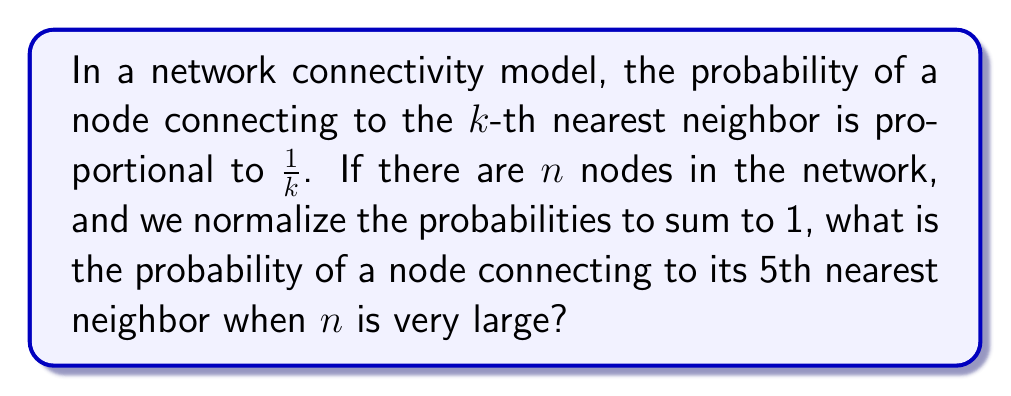What is the answer to this math problem? Let's approach this step-by-step:

1) The probability of connecting to the $k$-th nearest neighbor is proportional to $\frac{1}{k}$. This means we can write the probability as:

   $$P(k) = \frac{C}{k}$$

   where $C$ is a normalization constant.

2) To find $C$, we use the fact that the sum of all probabilities must equal 1:

   $$\sum_{k=1}^{n} P(k) = 1$$

3) Substituting our expression for $P(k)$:

   $$\sum_{k=1}^{n} \frac{C}{k} = 1$$

4) This sum is the partial sum of the harmonic series. As $n$ becomes very large, this sum approaches the $n$-th harmonic number $H_n$:

   $$C \cdot H_n = 1$$

5) The $n$-th harmonic number can be approximated for large $n$ as:

   $$H_n \approx \ln(n) + \gamma$$

   where $\gamma$ is the Euler-Mascheroni constant (approximately 0.5772).

6) So, for large $n$:

   $$C \cdot (\ln(n) + \gamma) \approx 1$$
   $$C \approx \frac{1}{\ln(n) + \gamma}$$

7) Now, the probability of connecting to the 5th nearest neighbor is:

   $$P(5) = \frac{C}{5} \approx \frac{1}{5(\ln(n) + \gamma)}$$

8) As $n$ becomes very large, $\ln(n)$ dominates $\gamma$, so we can approximate further:

   $$P(5) \approx \frac{1}{5\ln(n)}$$

This is our final approximation for very large $n$.
Answer: For very large $n$, the probability of a node connecting to its 5th nearest neighbor is approximately $\frac{1}{5\ln(n)}$. 